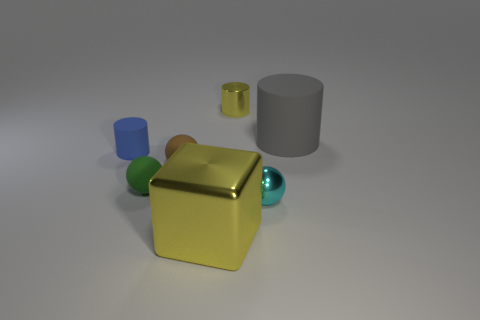What number of things are on the right side of the small blue rubber cylinder and in front of the small yellow thing?
Provide a succinct answer. 5. Is the size of the sphere that is in front of the green rubber object the same as the rubber cylinder that is to the left of the small green rubber ball?
Provide a short and direct response. Yes. What is the size of the yellow shiny object in front of the big matte object?
Offer a very short reply. Large. How many things are tiny things that are to the left of the brown matte object or cylinders to the right of the green matte object?
Your answer should be very brief. 4. Is there anything else of the same color as the large metal cube?
Provide a short and direct response. Yes. Are there the same number of blue rubber cylinders right of the small yellow metal cylinder and metallic cubes to the left of the tiny green ball?
Keep it short and to the point. Yes. Is the number of small cylinders to the left of the tiny green matte ball greater than the number of blue cylinders?
Offer a very short reply. No. How many objects are either matte things that are right of the small rubber cylinder or big gray rubber things?
Offer a very short reply. 3. What number of large gray cylinders are made of the same material as the yellow block?
Give a very brief answer. 0. There is a metal thing that is the same color as the tiny shiny cylinder; what shape is it?
Provide a short and direct response. Cube. 